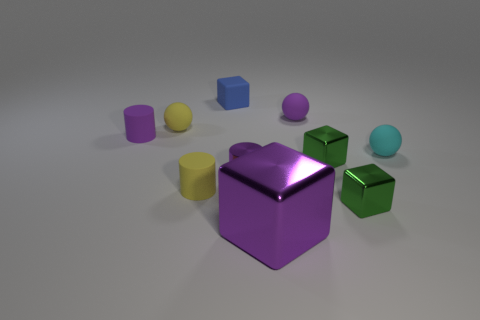Are there any other things that have the same size as the purple cube?
Give a very brief answer. No. There is a small ball that is the same color as the big thing; what is its material?
Provide a short and direct response. Rubber. What is the size of the shiny cube that is the same color as the metallic cylinder?
Provide a succinct answer. Large. Does the cylinder behind the tiny cyan matte thing have the same color as the shiny thing that is to the left of the big shiny cube?
Your response must be concise. Yes. Is there a cylinder of the same color as the big thing?
Give a very brief answer. Yes. Is the number of objects left of the big purple object less than the number of small objects that are on the left side of the tiny cyan rubber thing?
Provide a short and direct response. Yes. Are there any other things of the same color as the tiny rubber block?
Offer a very short reply. No. There is a tiny purple metallic thing; what shape is it?
Offer a very short reply. Cylinder. What color is the cube that is made of the same material as the small purple sphere?
Provide a short and direct response. Blue. Are there more small matte balls than small blue metal cubes?
Keep it short and to the point. Yes. 